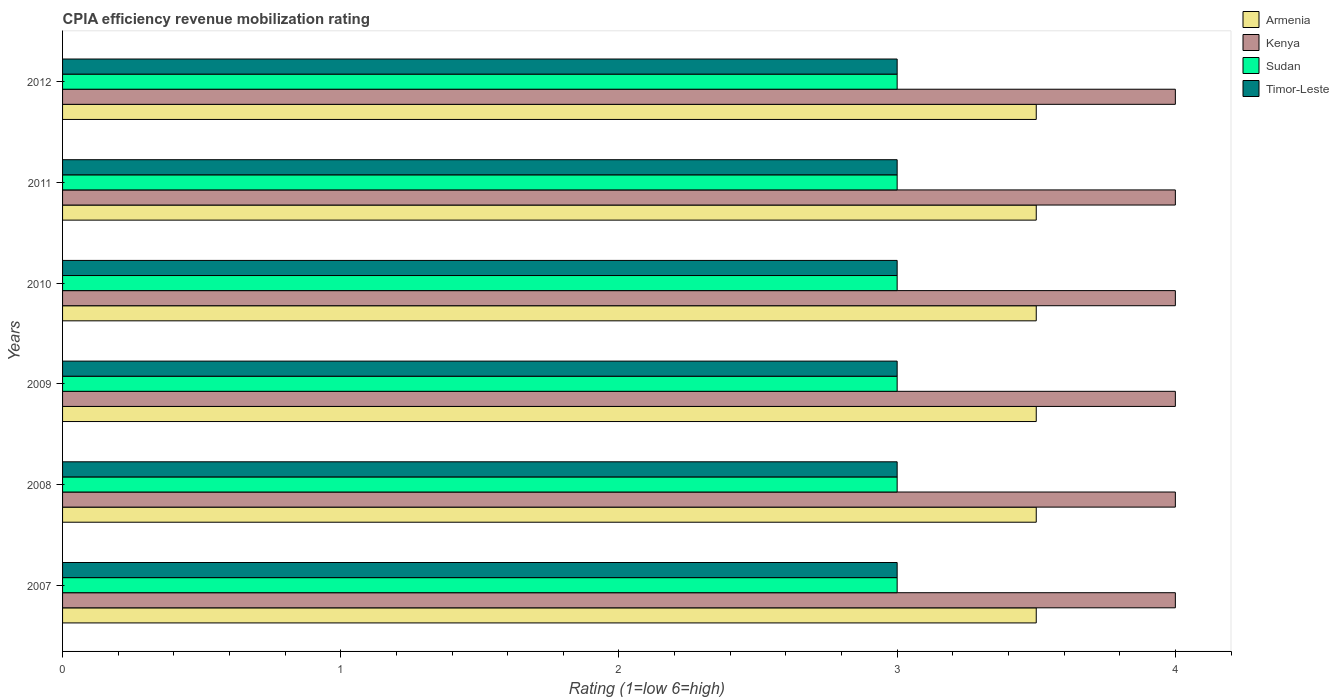Are the number of bars on each tick of the Y-axis equal?
Provide a succinct answer. Yes. How many bars are there on the 2nd tick from the bottom?
Ensure brevity in your answer.  4. What is the label of the 2nd group of bars from the top?
Give a very brief answer. 2011. Across all years, what is the maximum CPIA rating in Sudan?
Provide a succinct answer. 3. In which year was the CPIA rating in Armenia minimum?
Your response must be concise. 2007. What is the total CPIA rating in Kenya in the graph?
Your answer should be compact. 24. What is the average CPIA rating in Timor-Leste per year?
Provide a short and direct response. 3. In the year 2012, what is the difference between the CPIA rating in Sudan and CPIA rating in Kenya?
Make the answer very short. -1. In how many years, is the CPIA rating in Kenya greater than 1.2 ?
Provide a short and direct response. 6. What is the ratio of the CPIA rating in Kenya in 2008 to that in 2009?
Provide a succinct answer. 1. What is the difference between the highest and the lowest CPIA rating in Kenya?
Ensure brevity in your answer.  0. Is the sum of the CPIA rating in Armenia in 2008 and 2012 greater than the maximum CPIA rating in Kenya across all years?
Ensure brevity in your answer.  Yes. Is it the case that in every year, the sum of the CPIA rating in Armenia and CPIA rating in Timor-Leste is greater than the sum of CPIA rating in Kenya and CPIA rating in Sudan?
Your answer should be compact. No. What does the 2nd bar from the top in 2009 represents?
Your answer should be very brief. Sudan. What does the 3rd bar from the bottom in 2011 represents?
Provide a succinct answer. Sudan. How many bars are there?
Offer a very short reply. 24. Are all the bars in the graph horizontal?
Offer a terse response. Yes. How many years are there in the graph?
Provide a short and direct response. 6. What is the difference between two consecutive major ticks on the X-axis?
Ensure brevity in your answer.  1. Are the values on the major ticks of X-axis written in scientific E-notation?
Your answer should be very brief. No. Does the graph contain any zero values?
Give a very brief answer. No. How many legend labels are there?
Your response must be concise. 4. How are the legend labels stacked?
Keep it short and to the point. Vertical. What is the title of the graph?
Give a very brief answer. CPIA efficiency revenue mobilization rating. What is the Rating (1=low 6=high) in Sudan in 2007?
Give a very brief answer. 3. What is the Rating (1=low 6=high) in Timor-Leste in 2007?
Offer a very short reply. 3. What is the Rating (1=low 6=high) in Kenya in 2008?
Your response must be concise. 4. What is the Rating (1=low 6=high) in Timor-Leste in 2008?
Give a very brief answer. 3. What is the Rating (1=low 6=high) in Kenya in 2009?
Provide a succinct answer. 4. What is the Rating (1=low 6=high) in Timor-Leste in 2009?
Offer a terse response. 3. What is the Rating (1=low 6=high) in Sudan in 2010?
Keep it short and to the point. 3. What is the Rating (1=low 6=high) of Timor-Leste in 2010?
Give a very brief answer. 3. What is the Rating (1=low 6=high) of Armenia in 2011?
Offer a very short reply. 3.5. What is the Rating (1=low 6=high) of Timor-Leste in 2011?
Offer a terse response. 3. What is the Rating (1=low 6=high) in Armenia in 2012?
Ensure brevity in your answer.  3.5. What is the Rating (1=low 6=high) of Kenya in 2012?
Provide a succinct answer. 4. What is the Rating (1=low 6=high) in Sudan in 2012?
Your answer should be very brief. 3. Across all years, what is the minimum Rating (1=low 6=high) in Armenia?
Your response must be concise. 3.5. Across all years, what is the minimum Rating (1=low 6=high) in Kenya?
Ensure brevity in your answer.  4. Across all years, what is the minimum Rating (1=low 6=high) in Timor-Leste?
Provide a short and direct response. 3. What is the total Rating (1=low 6=high) in Armenia in the graph?
Provide a short and direct response. 21. What is the total Rating (1=low 6=high) in Sudan in the graph?
Your answer should be very brief. 18. What is the difference between the Rating (1=low 6=high) in Timor-Leste in 2007 and that in 2008?
Your response must be concise. 0. What is the difference between the Rating (1=low 6=high) of Kenya in 2007 and that in 2009?
Your answer should be compact. 0. What is the difference between the Rating (1=low 6=high) in Sudan in 2007 and that in 2009?
Keep it short and to the point. 0. What is the difference between the Rating (1=low 6=high) in Timor-Leste in 2007 and that in 2009?
Provide a succinct answer. 0. What is the difference between the Rating (1=low 6=high) in Armenia in 2007 and that in 2010?
Offer a terse response. 0. What is the difference between the Rating (1=low 6=high) of Timor-Leste in 2007 and that in 2010?
Make the answer very short. 0. What is the difference between the Rating (1=low 6=high) of Armenia in 2007 and that in 2011?
Ensure brevity in your answer.  0. What is the difference between the Rating (1=low 6=high) in Kenya in 2007 and that in 2011?
Provide a succinct answer. 0. What is the difference between the Rating (1=low 6=high) in Sudan in 2007 and that in 2011?
Offer a very short reply. 0. What is the difference between the Rating (1=low 6=high) in Timor-Leste in 2007 and that in 2011?
Your response must be concise. 0. What is the difference between the Rating (1=low 6=high) in Sudan in 2007 and that in 2012?
Offer a terse response. 0. What is the difference between the Rating (1=low 6=high) in Timor-Leste in 2007 and that in 2012?
Your answer should be very brief. 0. What is the difference between the Rating (1=low 6=high) of Kenya in 2008 and that in 2009?
Your answer should be compact. 0. What is the difference between the Rating (1=low 6=high) in Armenia in 2008 and that in 2010?
Provide a short and direct response. 0. What is the difference between the Rating (1=low 6=high) in Sudan in 2008 and that in 2010?
Provide a short and direct response. 0. What is the difference between the Rating (1=low 6=high) in Armenia in 2008 and that in 2011?
Give a very brief answer. 0. What is the difference between the Rating (1=low 6=high) of Sudan in 2008 and that in 2011?
Your response must be concise. 0. What is the difference between the Rating (1=low 6=high) of Timor-Leste in 2008 and that in 2011?
Provide a succinct answer. 0. What is the difference between the Rating (1=low 6=high) of Sudan in 2008 and that in 2012?
Offer a very short reply. 0. What is the difference between the Rating (1=low 6=high) in Timor-Leste in 2008 and that in 2012?
Your response must be concise. 0. What is the difference between the Rating (1=low 6=high) in Kenya in 2009 and that in 2011?
Keep it short and to the point. 0. What is the difference between the Rating (1=low 6=high) of Sudan in 2009 and that in 2011?
Offer a terse response. 0. What is the difference between the Rating (1=low 6=high) in Timor-Leste in 2009 and that in 2011?
Your answer should be very brief. 0. What is the difference between the Rating (1=low 6=high) in Kenya in 2009 and that in 2012?
Provide a succinct answer. 0. What is the difference between the Rating (1=low 6=high) of Sudan in 2009 and that in 2012?
Offer a very short reply. 0. What is the difference between the Rating (1=low 6=high) in Timor-Leste in 2009 and that in 2012?
Your answer should be compact. 0. What is the difference between the Rating (1=low 6=high) of Armenia in 2010 and that in 2011?
Give a very brief answer. 0. What is the difference between the Rating (1=low 6=high) in Kenya in 2010 and that in 2011?
Give a very brief answer. 0. What is the difference between the Rating (1=low 6=high) of Timor-Leste in 2010 and that in 2011?
Your answer should be compact. 0. What is the difference between the Rating (1=low 6=high) of Sudan in 2010 and that in 2012?
Provide a succinct answer. 0. What is the difference between the Rating (1=low 6=high) in Timor-Leste in 2010 and that in 2012?
Make the answer very short. 0. What is the difference between the Rating (1=low 6=high) of Armenia in 2011 and that in 2012?
Your answer should be very brief. 0. What is the difference between the Rating (1=low 6=high) in Kenya in 2011 and that in 2012?
Provide a short and direct response. 0. What is the difference between the Rating (1=low 6=high) in Sudan in 2011 and that in 2012?
Ensure brevity in your answer.  0. What is the difference between the Rating (1=low 6=high) in Armenia in 2007 and the Rating (1=low 6=high) in Timor-Leste in 2008?
Provide a succinct answer. 0.5. What is the difference between the Rating (1=low 6=high) of Kenya in 2007 and the Rating (1=low 6=high) of Sudan in 2008?
Make the answer very short. 1. What is the difference between the Rating (1=low 6=high) of Kenya in 2007 and the Rating (1=low 6=high) of Timor-Leste in 2008?
Give a very brief answer. 1. What is the difference between the Rating (1=low 6=high) in Sudan in 2007 and the Rating (1=low 6=high) in Timor-Leste in 2008?
Make the answer very short. 0. What is the difference between the Rating (1=low 6=high) of Armenia in 2007 and the Rating (1=low 6=high) of Kenya in 2009?
Keep it short and to the point. -0.5. What is the difference between the Rating (1=low 6=high) of Armenia in 2007 and the Rating (1=low 6=high) of Sudan in 2009?
Provide a succinct answer. 0.5. What is the difference between the Rating (1=low 6=high) of Armenia in 2007 and the Rating (1=low 6=high) of Timor-Leste in 2009?
Offer a very short reply. 0.5. What is the difference between the Rating (1=low 6=high) in Kenya in 2007 and the Rating (1=low 6=high) in Timor-Leste in 2009?
Provide a succinct answer. 1. What is the difference between the Rating (1=low 6=high) in Sudan in 2007 and the Rating (1=low 6=high) in Timor-Leste in 2009?
Offer a very short reply. 0. What is the difference between the Rating (1=low 6=high) in Armenia in 2007 and the Rating (1=low 6=high) in Kenya in 2010?
Your answer should be very brief. -0.5. What is the difference between the Rating (1=low 6=high) in Kenya in 2007 and the Rating (1=low 6=high) in Sudan in 2010?
Your answer should be compact. 1. What is the difference between the Rating (1=low 6=high) of Kenya in 2007 and the Rating (1=low 6=high) of Timor-Leste in 2010?
Your answer should be very brief. 1. What is the difference between the Rating (1=low 6=high) in Sudan in 2007 and the Rating (1=low 6=high) in Timor-Leste in 2010?
Offer a terse response. 0. What is the difference between the Rating (1=low 6=high) in Armenia in 2007 and the Rating (1=low 6=high) in Kenya in 2011?
Give a very brief answer. -0.5. What is the difference between the Rating (1=low 6=high) of Armenia in 2007 and the Rating (1=low 6=high) of Sudan in 2011?
Ensure brevity in your answer.  0.5. What is the difference between the Rating (1=low 6=high) in Kenya in 2007 and the Rating (1=low 6=high) in Sudan in 2011?
Offer a very short reply. 1. What is the difference between the Rating (1=low 6=high) in Sudan in 2007 and the Rating (1=low 6=high) in Timor-Leste in 2011?
Provide a short and direct response. 0. What is the difference between the Rating (1=low 6=high) in Kenya in 2007 and the Rating (1=low 6=high) in Sudan in 2012?
Provide a succinct answer. 1. What is the difference between the Rating (1=low 6=high) in Kenya in 2007 and the Rating (1=low 6=high) in Timor-Leste in 2012?
Offer a terse response. 1. What is the difference between the Rating (1=low 6=high) of Armenia in 2008 and the Rating (1=low 6=high) of Sudan in 2009?
Offer a terse response. 0.5. What is the difference between the Rating (1=low 6=high) in Armenia in 2008 and the Rating (1=low 6=high) in Timor-Leste in 2009?
Your response must be concise. 0.5. What is the difference between the Rating (1=low 6=high) in Sudan in 2008 and the Rating (1=low 6=high) in Timor-Leste in 2009?
Your answer should be compact. 0. What is the difference between the Rating (1=low 6=high) in Armenia in 2008 and the Rating (1=low 6=high) in Sudan in 2010?
Your response must be concise. 0.5. What is the difference between the Rating (1=low 6=high) of Armenia in 2008 and the Rating (1=low 6=high) of Timor-Leste in 2010?
Your response must be concise. 0.5. What is the difference between the Rating (1=low 6=high) of Kenya in 2008 and the Rating (1=low 6=high) of Timor-Leste in 2010?
Provide a succinct answer. 1. What is the difference between the Rating (1=low 6=high) in Sudan in 2008 and the Rating (1=low 6=high) in Timor-Leste in 2010?
Your response must be concise. 0. What is the difference between the Rating (1=low 6=high) of Kenya in 2008 and the Rating (1=low 6=high) of Sudan in 2011?
Provide a succinct answer. 1. What is the difference between the Rating (1=low 6=high) in Armenia in 2008 and the Rating (1=low 6=high) in Timor-Leste in 2012?
Offer a terse response. 0.5. What is the difference between the Rating (1=low 6=high) of Kenya in 2008 and the Rating (1=low 6=high) of Timor-Leste in 2012?
Your answer should be compact. 1. What is the difference between the Rating (1=low 6=high) of Armenia in 2009 and the Rating (1=low 6=high) of Sudan in 2010?
Provide a short and direct response. 0.5. What is the difference between the Rating (1=low 6=high) in Armenia in 2009 and the Rating (1=low 6=high) in Timor-Leste in 2010?
Your response must be concise. 0.5. What is the difference between the Rating (1=low 6=high) in Kenya in 2009 and the Rating (1=low 6=high) in Timor-Leste in 2010?
Your answer should be compact. 1. What is the difference between the Rating (1=low 6=high) of Sudan in 2009 and the Rating (1=low 6=high) of Timor-Leste in 2010?
Your answer should be very brief. 0. What is the difference between the Rating (1=low 6=high) in Armenia in 2009 and the Rating (1=low 6=high) in Kenya in 2011?
Offer a very short reply. -0.5. What is the difference between the Rating (1=low 6=high) of Armenia in 2009 and the Rating (1=low 6=high) of Timor-Leste in 2011?
Provide a short and direct response. 0.5. What is the difference between the Rating (1=low 6=high) in Armenia in 2009 and the Rating (1=low 6=high) in Kenya in 2012?
Keep it short and to the point. -0.5. What is the difference between the Rating (1=low 6=high) in Armenia in 2009 and the Rating (1=low 6=high) in Sudan in 2012?
Give a very brief answer. 0.5. What is the difference between the Rating (1=low 6=high) in Kenya in 2009 and the Rating (1=low 6=high) in Sudan in 2012?
Give a very brief answer. 1. What is the difference between the Rating (1=low 6=high) of Armenia in 2010 and the Rating (1=low 6=high) of Kenya in 2011?
Offer a terse response. -0.5. What is the difference between the Rating (1=low 6=high) of Kenya in 2010 and the Rating (1=low 6=high) of Timor-Leste in 2011?
Your answer should be very brief. 1. What is the difference between the Rating (1=low 6=high) of Armenia in 2011 and the Rating (1=low 6=high) of Kenya in 2012?
Offer a very short reply. -0.5. What is the difference between the Rating (1=low 6=high) of Armenia in 2011 and the Rating (1=low 6=high) of Sudan in 2012?
Your answer should be compact. 0.5. What is the difference between the Rating (1=low 6=high) in Armenia in 2011 and the Rating (1=low 6=high) in Timor-Leste in 2012?
Offer a very short reply. 0.5. What is the difference between the Rating (1=low 6=high) of Kenya in 2011 and the Rating (1=low 6=high) of Sudan in 2012?
Make the answer very short. 1. What is the average Rating (1=low 6=high) in Armenia per year?
Provide a succinct answer. 3.5. What is the average Rating (1=low 6=high) in Kenya per year?
Your response must be concise. 4. What is the average Rating (1=low 6=high) in Sudan per year?
Provide a short and direct response. 3. In the year 2007, what is the difference between the Rating (1=low 6=high) of Armenia and Rating (1=low 6=high) of Sudan?
Your answer should be compact. 0.5. In the year 2007, what is the difference between the Rating (1=low 6=high) in Armenia and Rating (1=low 6=high) in Timor-Leste?
Provide a short and direct response. 0.5. In the year 2007, what is the difference between the Rating (1=low 6=high) in Kenya and Rating (1=low 6=high) in Sudan?
Keep it short and to the point. 1. In the year 2007, what is the difference between the Rating (1=low 6=high) of Sudan and Rating (1=low 6=high) of Timor-Leste?
Your answer should be compact. 0. In the year 2008, what is the difference between the Rating (1=low 6=high) of Armenia and Rating (1=low 6=high) of Sudan?
Make the answer very short. 0.5. In the year 2008, what is the difference between the Rating (1=low 6=high) of Armenia and Rating (1=low 6=high) of Timor-Leste?
Provide a short and direct response. 0.5. In the year 2008, what is the difference between the Rating (1=low 6=high) of Kenya and Rating (1=low 6=high) of Timor-Leste?
Ensure brevity in your answer.  1. In the year 2009, what is the difference between the Rating (1=low 6=high) of Armenia and Rating (1=low 6=high) of Sudan?
Provide a succinct answer. 0.5. In the year 2009, what is the difference between the Rating (1=low 6=high) in Kenya and Rating (1=low 6=high) in Sudan?
Ensure brevity in your answer.  1. In the year 2010, what is the difference between the Rating (1=low 6=high) in Armenia and Rating (1=low 6=high) in Sudan?
Ensure brevity in your answer.  0.5. In the year 2010, what is the difference between the Rating (1=low 6=high) of Kenya and Rating (1=low 6=high) of Sudan?
Give a very brief answer. 1. In the year 2011, what is the difference between the Rating (1=low 6=high) in Armenia and Rating (1=low 6=high) in Timor-Leste?
Offer a very short reply. 0.5. In the year 2011, what is the difference between the Rating (1=low 6=high) in Kenya and Rating (1=low 6=high) in Sudan?
Your answer should be very brief. 1. In the year 2011, what is the difference between the Rating (1=low 6=high) of Kenya and Rating (1=low 6=high) of Timor-Leste?
Offer a terse response. 1. In the year 2011, what is the difference between the Rating (1=low 6=high) in Sudan and Rating (1=low 6=high) in Timor-Leste?
Make the answer very short. 0. In the year 2012, what is the difference between the Rating (1=low 6=high) in Armenia and Rating (1=low 6=high) in Kenya?
Offer a terse response. -0.5. In the year 2012, what is the difference between the Rating (1=low 6=high) in Armenia and Rating (1=low 6=high) in Timor-Leste?
Ensure brevity in your answer.  0.5. In the year 2012, what is the difference between the Rating (1=low 6=high) of Kenya and Rating (1=low 6=high) of Sudan?
Ensure brevity in your answer.  1. In the year 2012, what is the difference between the Rating (1=low 6=high) in Kenya and Rating (1=low 6=high) in Timor-Leste?
Give a very brief answer. 1. What is the ratio of the Rating (1=low 6=high) of Armenia in 2007 to that in 2008?
Your answer should be very brief. 1. What is the ratio of the Rating (1=low 6=high) of Kenya in 2007 to that in 2009?
Give a very brief answer. 1. What is the ratio of the Rating (1=low 6=high) in Sudan in 2007 to that in 2009?
Make the answer very short. 1. What is the ratio of the Rating (1=low 6=high) of Timor-Leste in 2007 to that in 2009?
Give a very brief answer. 1. What is the ratio of the Rating (1=low 6=high) of Sudan in 2007 to that in 2010?
Your response must be concise. 1. What is the ratio of the Rating (1=low 6=high) in Timor-Leste in 2007 to that in 2010?
Make the answer very short. 1. What is the ratio of the Rating (1=low 6=high) in Armenia in 2007 to that in 2012?
Offer a very short reply. 1. What is the ratio of the Rating (1=low 6=high) in Kenya in 2007 to that in 2012?
Your answer should be compact. 1. What is the ratio of the Rating (1=low 6=high) of Armenia in 2008 to that in 2009?
Offer a terse response. 1. What is the ratio of the Rating (1=low 6=high) in Sudan in 2008 to that in 2009?
Keep it short and to the point. 1. What is the ratio of the Rating (1=low 6=high) in Armenia in 2008 to that in 2010?
Ensure brevity in your answer.  1. What is the ratio of the Rating (1=low 6=high) in Kenya in 2008 to that in 2010?
Make the answer very short. 1. What is the ratio of the Rating (1=low 6=high) in Sudan in 2008 to that in 2010?
Keep it short and to the point. 1. What is the ratio of the Rating (1=low 6=high) of Timor-Leste in 2008 to that in 2010?
Make the answer very short. 1. What is the ratio of the Rating (1=low 6=high) of Kenya in 2008 to that in 2011?
Your response must be concise. 1. What is the ratio of the Rating (1=low 6=high) in Timor-Leste in 2008 to that in 2011?
Provide a short and direct response. 1. What is the ratio of the Rating (1=low 6=high) in Armenia in 2008 to that in 2012?
Your answer should be compact. 1. What is the ratio of the Rating (1=low 6=high) in Kenya in 2008 to that in 2012?
Make the answer very short. 1. What is the ratio of the Rating (1=low 6=high) of Armenia in 2009 to that in 2010?
Provide a short and direct response. 1. What is the ratio of the Rating (1=low 6=high) of Armenia in 2009 to that in 2011?
Provide a succinct answer. 1. What is the ratio of the Rating (1=low 6=high) of Kenya in 2009 to that in 2011?
Your response must be concise. 1. What is the ratio of the Rating (1=low 6=high) in Sudan in 2009 to that in 2011?
Your response must be concise. 1. What is the ratio of the Rating (1=low 6=high) of Timor-Leste in 2009 to that in 2011?
Offer a terse response. 1. What is the ratio of the Rating (1=low 6=high) in Kenya in 2010 to that in 2011?
Provide a succinct answer. 1. What is the ratio of the Rating (1=low 6=high) of Sudan in 2010 to that in 2011?
Make the answer very short. 1. What is the ratio of the Rating (1=low 6=high) in Timor-Leste in 2010 to that in 2011?
Make the answer very short. 1. What is the ratio of the Rating (1=low 6=high) of Sudan in 2010 to that in 2012?
Provide a short and direct response. 1. What is the ratio of the Rating (1=low 6=high) in Armenia in 2011 to that in 2012?
Your answer should be compact. 1. What is the ratio of the Rating (1=low 6=high) of Timor-Leste in 2011 to that in 2012?
Your answer should be very brief. 1. What is the difference between the highest and the second highest Rating (1=low 6=high) of Kenya?
Your answer should be compact. 0. What is the difference between the highest and the second highest Rating (1=low 6=high) of Timor-Leste?
Keep it short and to the point. 0. What is the difference between the highest and the lowest Rating (1=low 6=high) in Armenia?
Provide a short and direct response. 0. What is the difference between the highest and the lowest Rating (1=low 6=high) in Kenya?
Make the answer very short. 0. 